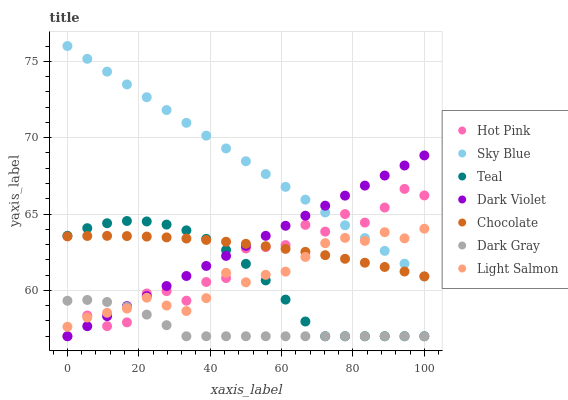Does Dark Gray have the minimum area under the curve?
Answer yes or no. Yes. Does Sky Blue have the maximum area under the curve?
Answer yes or no. Yes. Does Hot Pink have the minimum area under the curve?
Answer yes or no. No. Does Hot Pink have the maximum area under the curve?
Answer yes or no. No. Is Dark Violet the smoothest?
Answer yes or no. Yes. Is Hot Pink the roughest?
Answer yes or no. Yes. Is Hot Pink the smoothest?
Answer yes or no. No. Is Dark Violet the roughest?
Answer yes or no. No. Does Hot Pink have the lowest value?
Answer yes or no. Yes. Does Chocolate have the lowest value?
Answer yes or no. No. Does Sky Blue have the highest value?
Answer yes or no. Yes. Does Hot Pink have the highest value?
Answer yes or no. No. Is Teal less than Sky Blue?
Answer yes or no. Yes. Is Sky Blue greater than Dark Gray?
Answer yes or no. Yes. Does Hot Pink intersect Chocolate?
Answer yes or no. Yes. Is Hot Pink less than Chocolate?
Answer yes or no. No. Is Hot Pink greater than Chocolate?
Answer yes or no. No. Does Teal intersect Sky Blue?
Answer yes or no. No. 